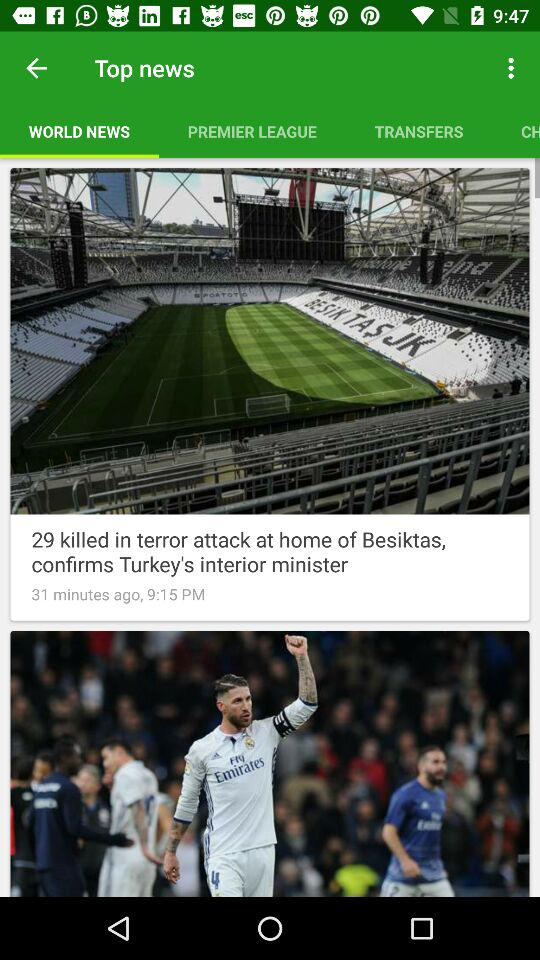What is the selected option in "Top news"? The selected option is "WORLD NEWS". 